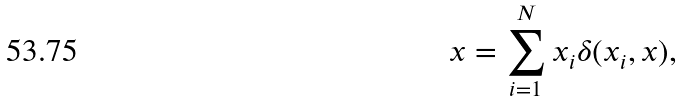<formula> <loc_0><loc_0><loc_500><loc_500>x = \sum _ { i = 1 } ^ { N } x _ { i } \delta ( x _ { i } , x ) ,</formula> 